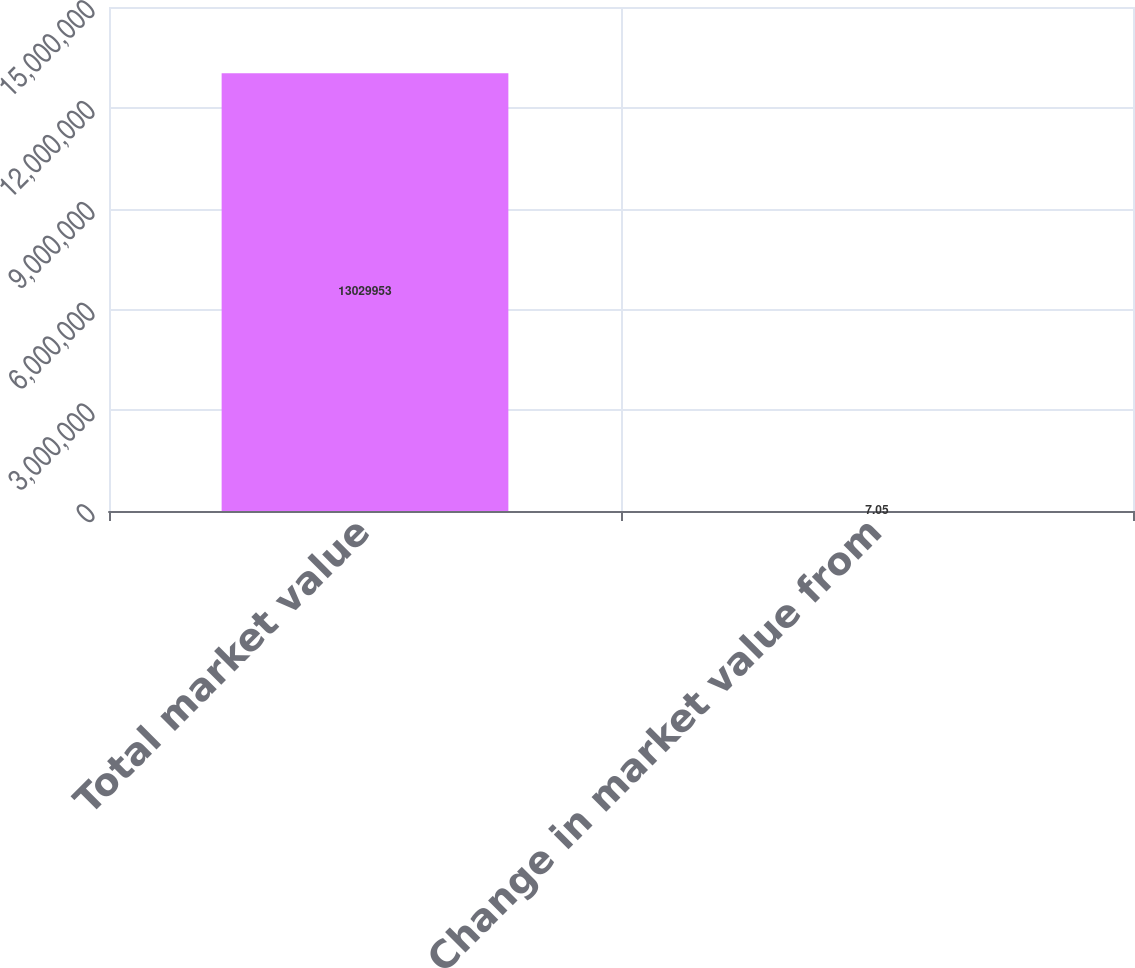Convert chart to OTSL. <chart><loc_0><loc_0><loc_500><loc_500><bar_chart><fcel>Total market value<fcel>Change in market value from<nl><fcel>1.303e+07<fcel>7.05<nl></chart> 